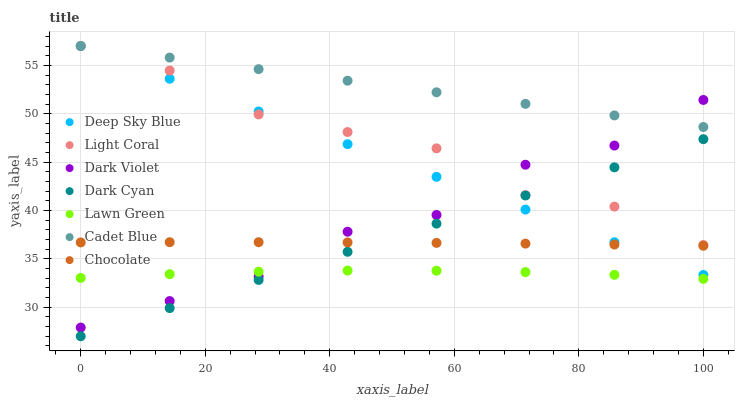Does Lawn Green have the minimum area under the curve?
Answer yes or no. Yes. Does Cadet Blue have the maximum area under the curve?
Answer yes or no. Yes. Does Dark Violet have the minimum area under the curve?
Answer yes or no. No. Does Dark Violet have the maximum area under the curve?
Answer yes or no. No. Is Deep Sky Blue the smoothest?
Answer yes or no. Yes. Is Dark Violet the roughest?
Answer yes or no. Yes. Is Cadet Blue the smoothest?
Answer yes or no. No. Is Cadet Blue the roughest?
Answer yes or no. No. Does Dark Cyan have the lowest value?
Answer yes or no. Yes. Does Dark Violet have the lowest value?
Answer yes or no. No. Does Deep Sky Blue have the highest value?
Answer yes or no. Yes. Does Dark Violet have the highest value?
Answer yes or no. No. Is Lawn Green less than Cadet Blue?
Answer yes or no. Yes. Is Cadet Blue greater than Dark Cyan?
Answer yes or no. Yes. Does Cadet Blue intersect Light Coral?
Answer yes or no. Yes. Is Cadet Blue less than Light Coral?
Answer yes or no. No. Is Cadet Blue greater than Light Coral?
Answer yes or no. No. Does Lawn Green intersect Cadet Blue?
Answer yes or no. No. 